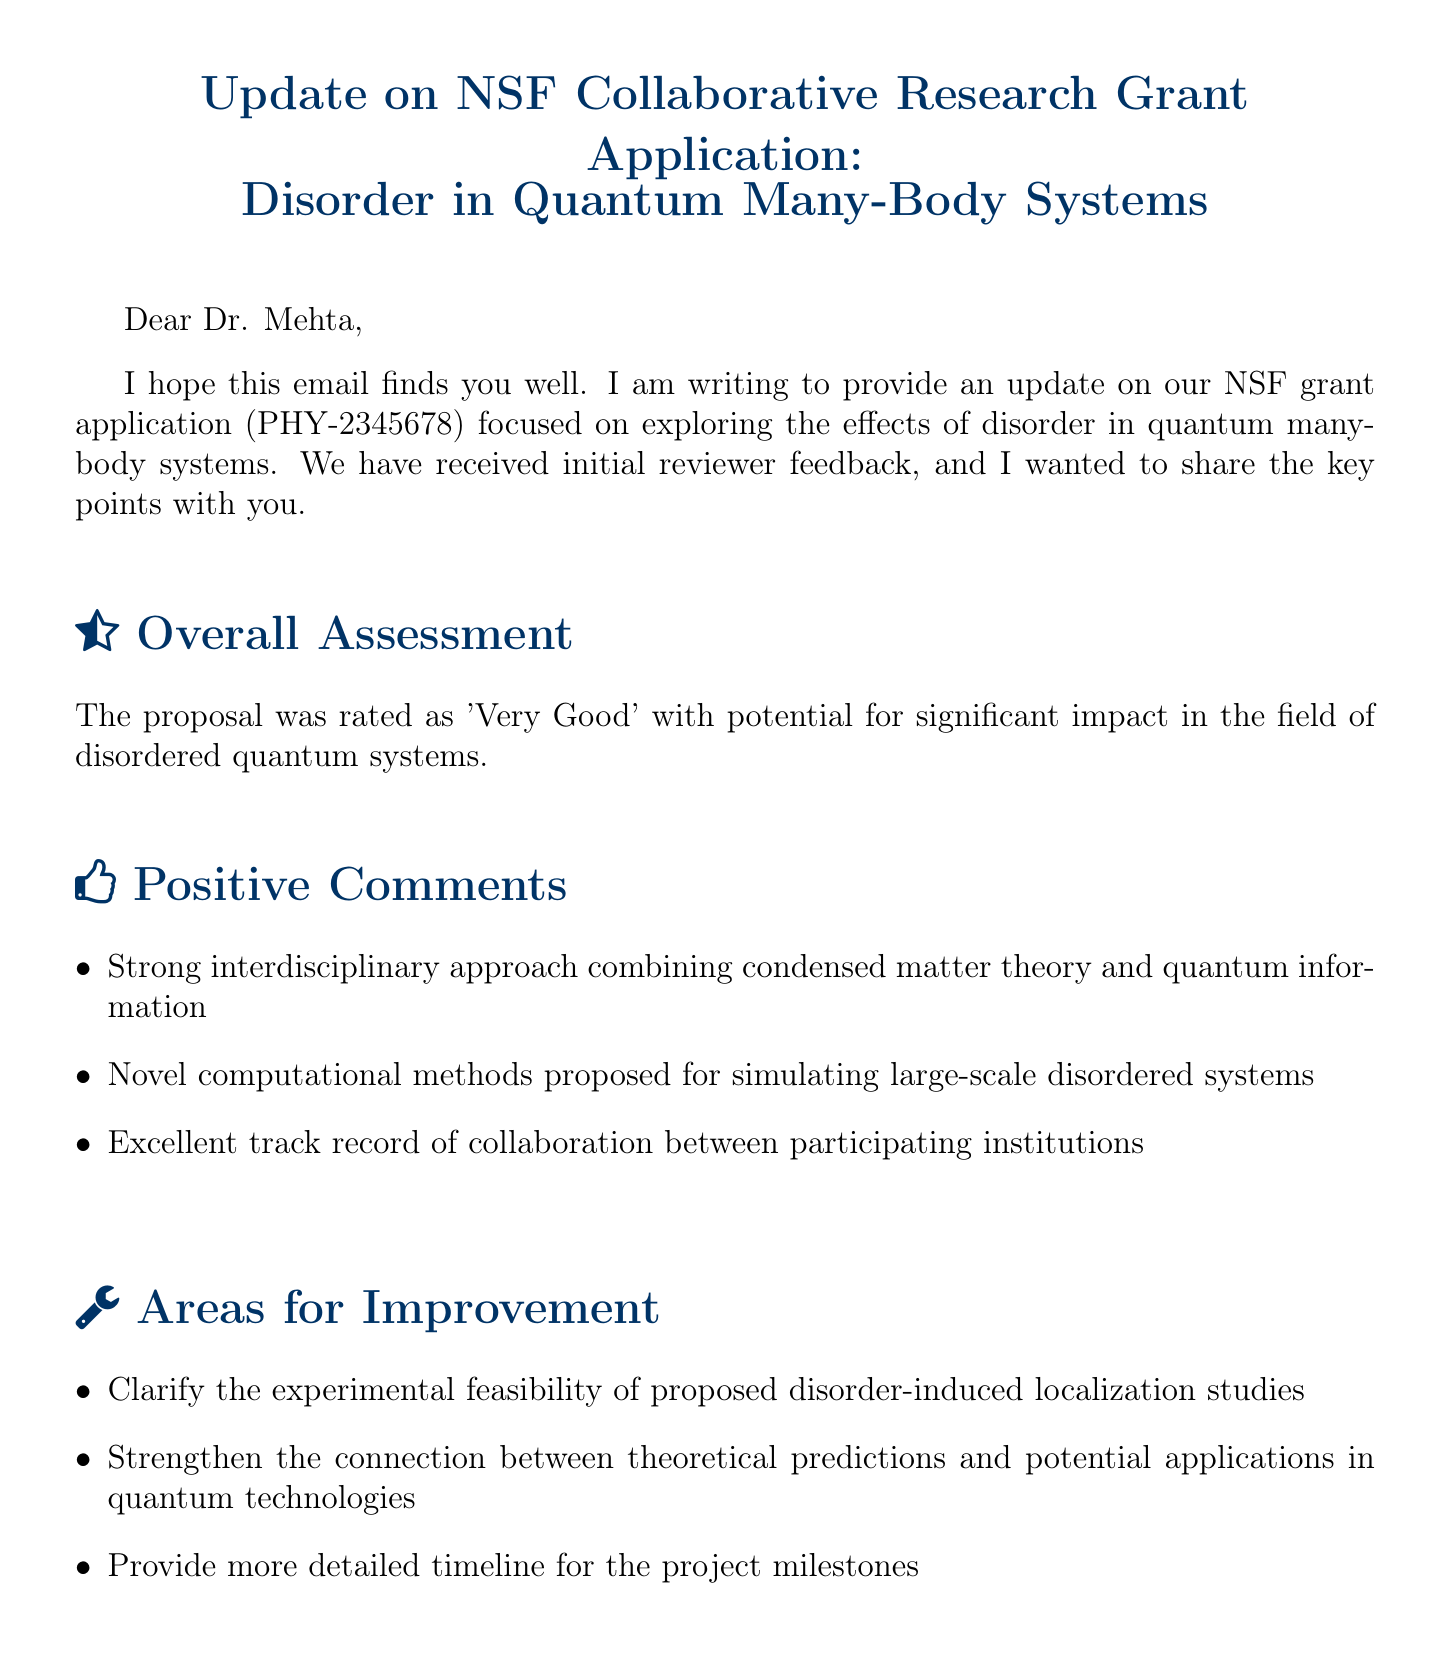What is the grant application number? The grant application number is clearly stated in the document as PHY-2345678.
Answer: PHY-2345678 What was the overall assessment of the proposal? The overall assessment indicates that the proposal was rated as 'Very Good' with potential for significant impact.
Answer: Very Good What are some positive comments about the proposal? The document lists positive comments, including the strong interdisciplinary approach and novel computational methods.
Answer: Strong interdisciplinary approach combining condensed matter theory and quantum information What areas for improvement are mentioned? The document specifies areas for improvement, one being to clarify the experimental feasibility of certain studies.
Answer: Clarify the experimental feasibility of proposed disorder-induced localization studies What are the next steps outlined in the email? The email outlines several next steps, including scheduling a meeting with co-PIs.
Answer: Schedule a meeting with co-PIs from MIT and Caltech to address reviewer comments What does the funding outlook indicate about chances for funding? The funding outlook mentions that chances for funding appear promising if certain feedback is addressed.
Answer: Promising Who is the sender of the email? The sender of the email is identified at the end of the document.
Answer: Dr. Sarah Chen What is the main focus of the grant application? The main focus is centered on disorder in quantum many-body systems, as stated in the subject line.
Answer: Disorder in Quantum Many-Body Systems 